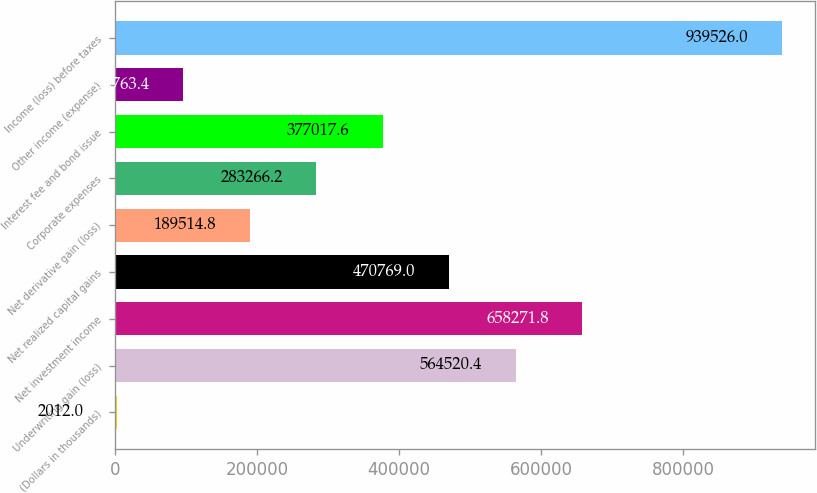Convert chart to OTSL. <chart><loc_0><loc_0><loc_500><loc_500><bar_chart><fcel>(Dollars in thousands)<fcel>Underwriting gain (loss)<fcel>Net investment income<fcel>Net realized capital gains<fcel>Net derivative gain (loss)<fcel>Corporate expenses<fcel>Interest fee and bond issue<fcel>Other income (expense)<fcel>Income (loss) before taxes<nl><fcel>2012<fcel>564520<fcel>658272<fcel>470769<fcel>189515<fcel>283266<fcel>377018<fcel>95763.4<fcel>939526<nl></chart> 